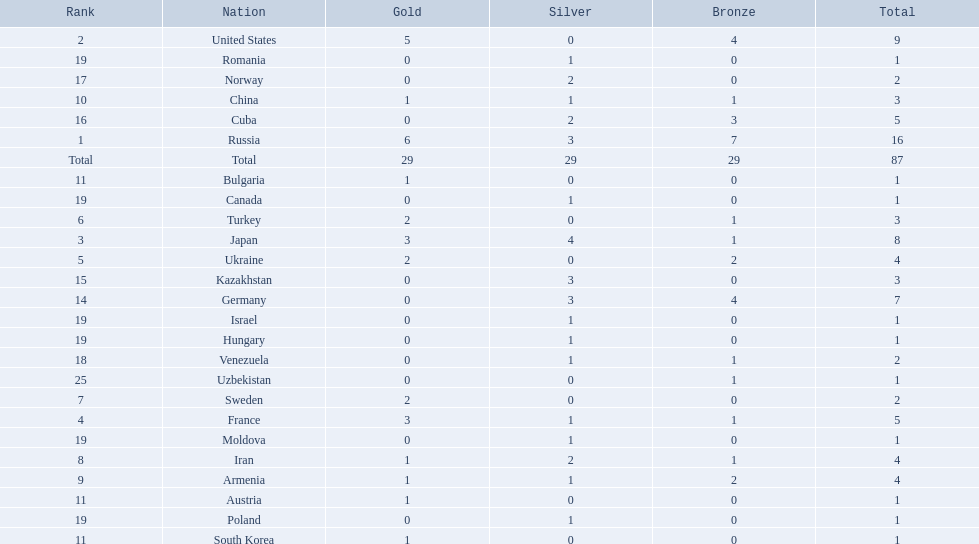Which nations participated in the championships? Russia, United States, Japan, France, Ukraine, Turkey, Sweden, Iran, Armenia, China, Austria, Bulgaria, South Korea, Germany, Kazakhstan, Cuba, Norway, Venezuela, Canada, Hungary, Israel, Moldova, Poland, Romania, Uzbekistan. How many bronze medals did they receive? 7, 4, 1, 1, 2, 1, 0, 1, 2, 1, 0, 0, 0, 4, 0, 3, 0, 1, 0, 0, 0, 0, 0, 0, 1, 29. How many in total? 16, 9, 8, 5, 4, 3, 2, 4, 4, 3, 1, 1, 1, 7, 3, 5, 2, 2, 1, 1, 1, 1, 1, 1, 1. And which team won only one medal -- the bronze? Uzbekistan. 